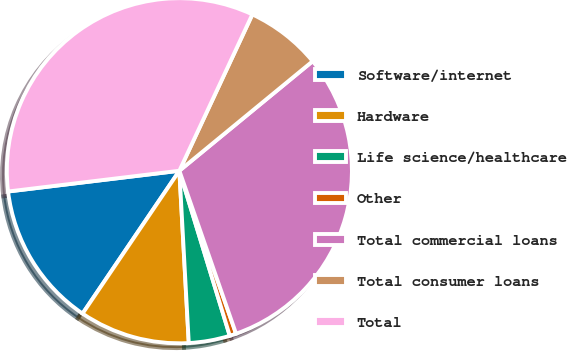Convert chart. <chart><loc_0><loc_0><loc_500><loc_500><pie_chart><fcel>Software/internet<fcel>Hardware<fcel>Life science/healthcare<fcel>Other<fcel>Total commercial loans<fcel>Total consumer loans<fcel>Total<nl><fcel>13.6%<fcel>10.35%<fcel>3.85%<fcel>0.61%<fcel>30.62%<fcel>7.1%<fcel>33.87%<nl></chart> 